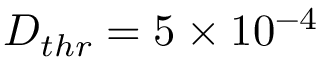<formula> <loc_0><loc_0><loc_500><loc_500>D _ { t h r } = 5 \times 1 0 ^ { - 4 }</formula> 